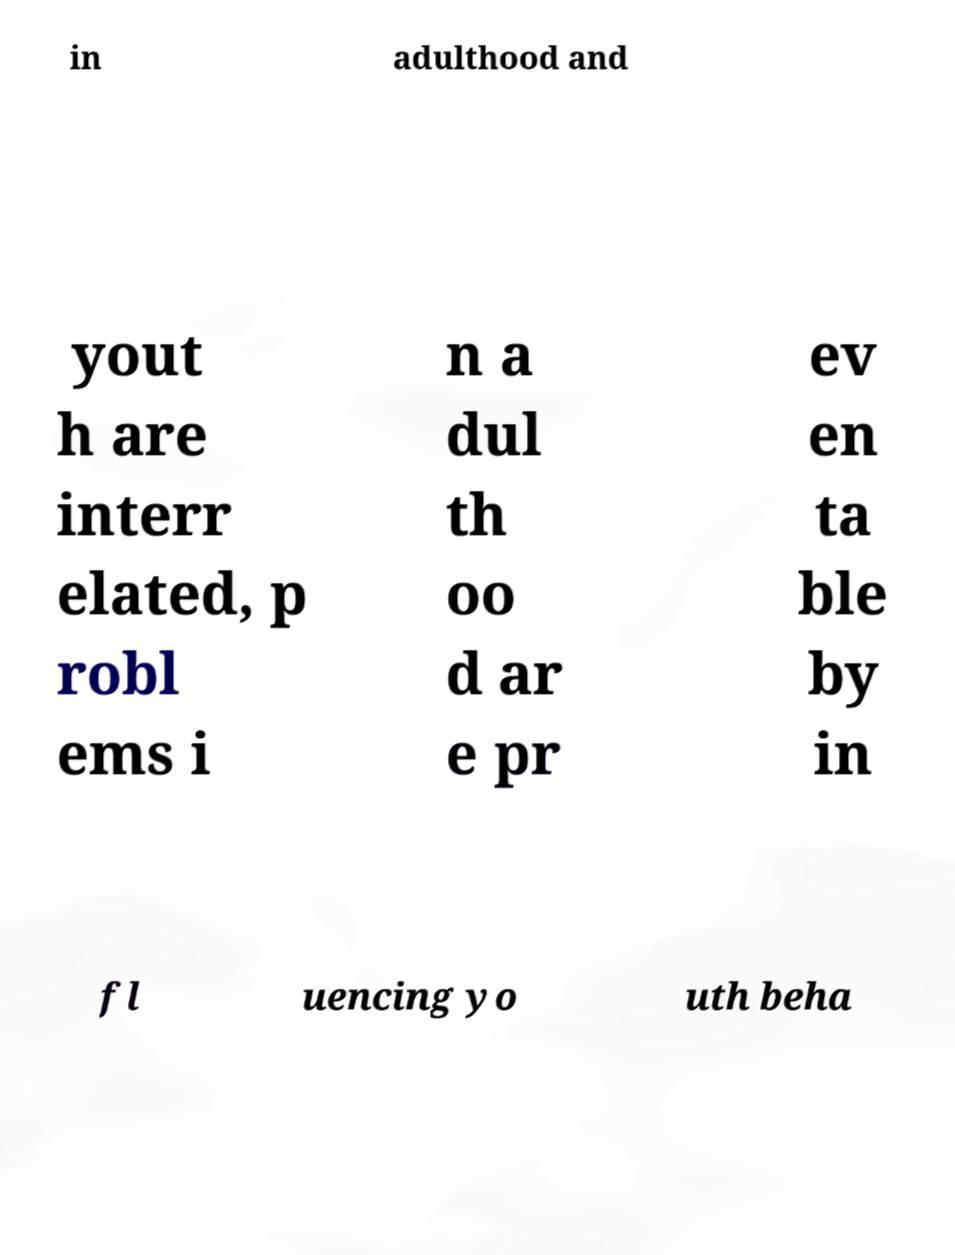I need the written content from this picture converted into text. Can you do that? in adulthood and yout h are interr elated, p robl ems i n a dul th oo d ar e pr ev en ta ble by in fl uencing yo uth beha 